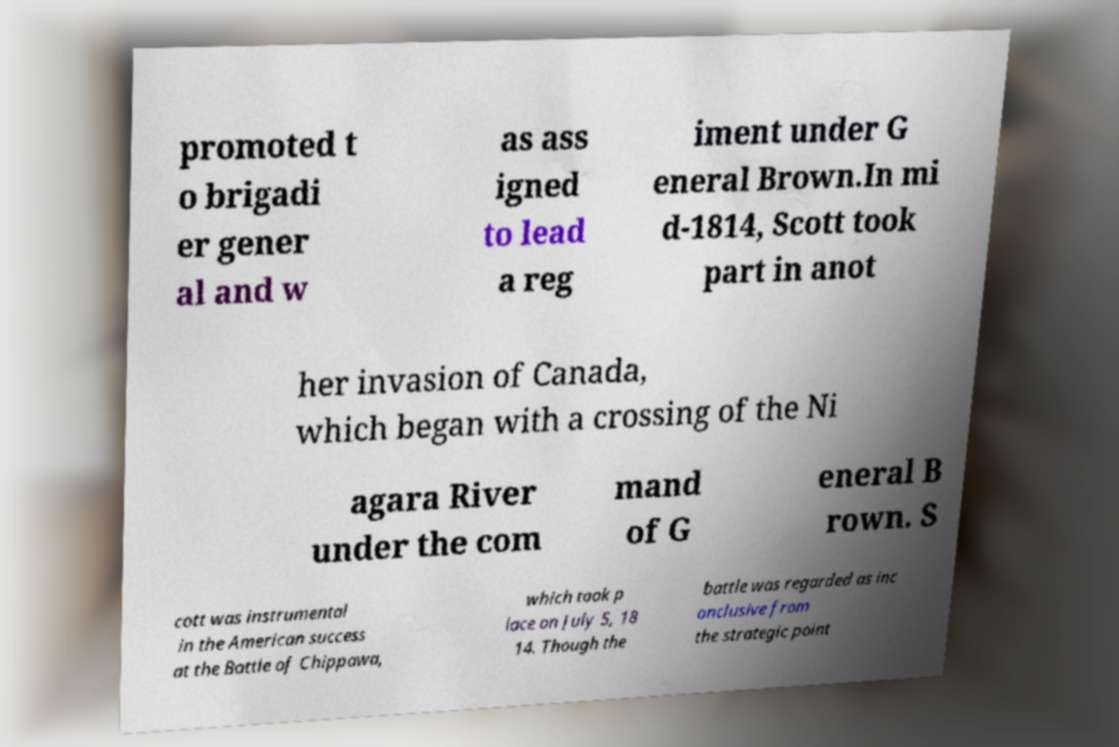Can you accurately transcribe the text from the provided image for me? promoted t o brigadi er gener al and w as ass igned to lead a reg iment under G eneral Brown.In mi d-1814, Scott took part in anot her invasion of Canada, which began with a crossing of the Ni agara River under the com mand of G eneral B rown. S cott was instrumental in the American success at the Battle of Chippawa, which took p lace on July 5, 18 14. Though the battle was regarded as inc onclusive from the strategic point 